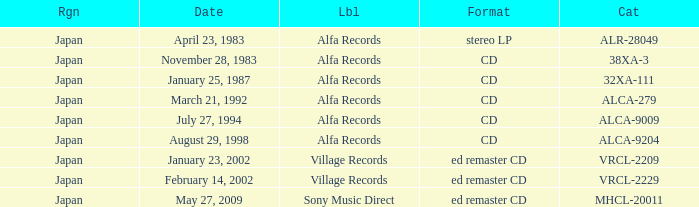What is the format of the date February 14, 2002? Ed remaster cd. 